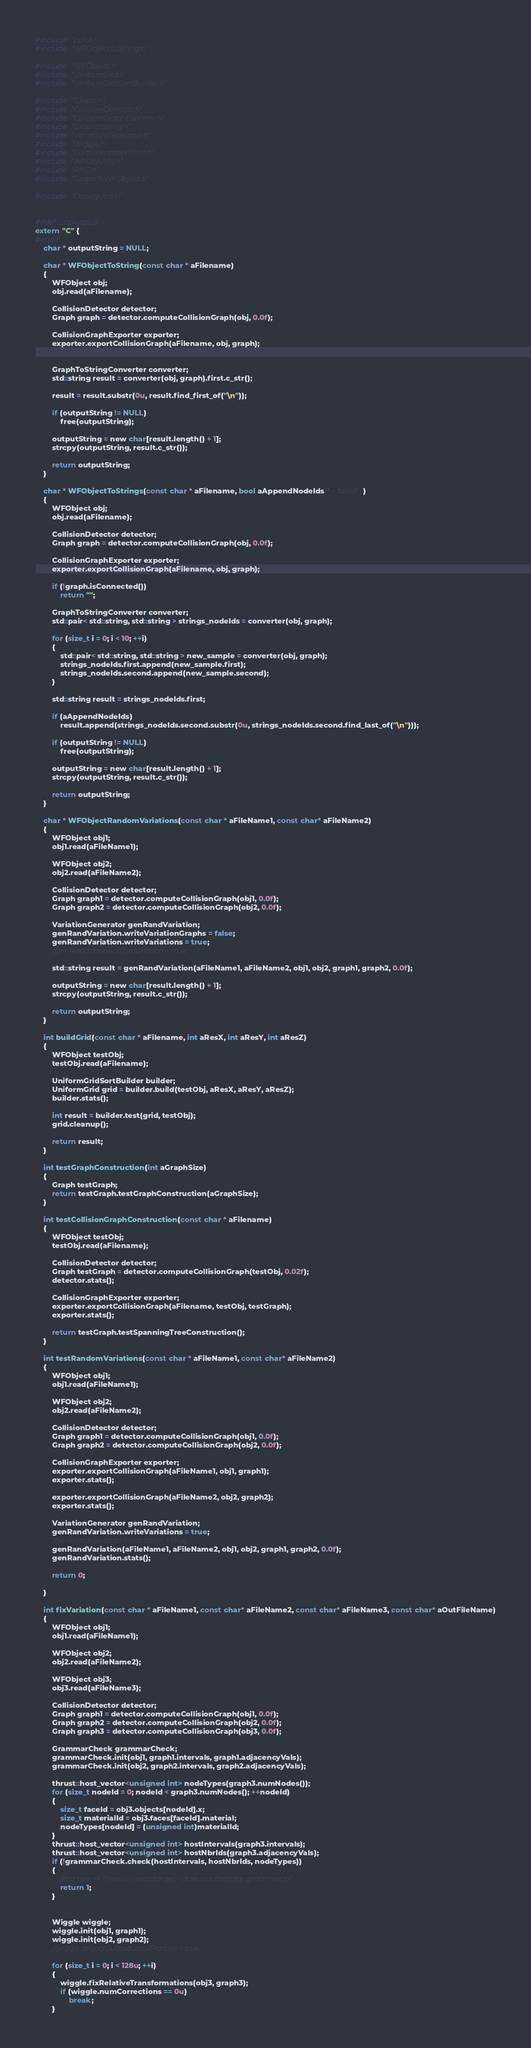<code> <loc_0><loc_0><loc_500><loc_500><_Cuda_>#include "pch.h"
#include "WFObjectToString.h"

#include "WFObject.h"
#include "UniformGrid.h"
#include "UniformGridSortBuilder.h"

#include "Graph.h"
#include "CollisionDetector.h"
#include "CollisionGraphExporter.h"
#include "Graph2String.h"
#include "VariationGenerator.h"
#include "Wiggle.h"
#include "PartOrientationUtils.h"
#include "WFObjUtils.h"
#include "RNG.h"
#include "GraphToWFObject.h"

#include "DebugUtils.h"


#ifdef __cplusplus
extern "C" {
#endif
	char * outputString = NULL;

	char * WFObjectToString(const char * aFilename)
	{
		WFObject obj;
		obj.read(aFilename);

		CollisionDetector detector;
		Graph graph = detector.computeCollisionGraph(obj, 0.0f);

		CollisionGraphExporter exporter;
		exporter.exportCollisionGraph(aFilename, obj, graph);


		GraphToStringConverter converter;
		std::string result = converter(obj, graph).first.c_str();
		
		result = result.substr(0u, result.find_first_of("\n"));

		if (outputString != NULL)
			free(outputString);

		outputString = new char[result.length() + 1];
		strcpy(outputString, result.c_str());

		return outputString;
	}

	char * WFObjectToStrings(const char * aFilename, bool aAppendNodeIds/* = false*/)
	{
		WFObject obj;
		obj.read(aFilename);

		CollisionDetector detector;
		Graph graph = detector.computeCollisionGraph(obj, 0.0f);

		CollisionGraphExporter exporter;
		exporter.exportCollisionGraph(aFilename, obj, graph);

		if (!graph.isConnected())
			return "";

		GraphToStringConverter converter;
		std::pair< std::string, std::string > strings_nodeIds = converter(obj, graph);

		for (size_t i = 0; i < 10; ++i)
		{
			std::pair< std::string, std::string > new_sample = converter(obj, graph);
			strings_nodeIds.first.append(new_sample.first);
			strings_nodeIds.second.append(new_sample.second);
		}

		std::string result = strings_nodeIds.first;

		if (aAppendNodeIds)
			result.append(strings_nodeIds.second.substr(0u, strings_nodeIds.second.find_last_of("\n")));

		if (outputString != NULL)
			free(outputString);

		outputString = new char[result.length() + 1];
		strcpy(outputString, result.c_str());

		return outputString;
	}

	char * WFObjectRandomVariations(const char * aFileName1, const char* aFileName2)
	{
		WFObject obj1;
		obj1.read(aFileName1);

		WFObject obj2;
		obj2.read(aFileName2);

		CollisionDetector detector;
		Graph graph1 = detector.computeCollisionGraph(obj1, 0.0f);
		Graph graph2 = detector.computeCollisionGraph(obj2, 0.0f);

		VariationGenerator genRandVariation;
		genRandVariation.writeVariationGraphs = false;
		genRandVariation.writeVariations = true;
		//genRandVariation.fixVariation = true;

		std::string result = genRandVariation(aFileName1, aFileName2, obj1, obj2, graph1, graph2, 0.0f);

		outputString = new char[result.length() + 1];
		strcpy(outputString, result.c_str());

		return outputString;
	}

	int buildGrid(const char * aFilename, int aResX, int aResY, int aResZ)
	{
		WFObject testObj;
		testObj.read(aFilename);

		UniformGridSortBuilder builder;
		UniformGrid grid = builder.build(testObj, aResX, aResY, aResZ);
		builder.stats();

		int result = builder.test(grid, testObj);
		grid.cleanup();

		return result;
	}

	int testGraphConstruction(int aGraphSize)
	{
		Graph testGraph;
		return testGraph.testGraphConstruction(aGraphSize);
	}

	int testCollisionGraphConstruction(const char * aFilename)
	{
		WFObject testObj;
		testObj.read(aFilename);

		CollisionDetector detector;
		Graph testGraph = detector.computeCollisionGraph(testObj, 0.02f);
		detector.stats();		

		CollisionGraphExporter exporter;
		exporter.exportCollisionGraph(aFilename, testObj, testGraph);
		exporter.stats();

		return testGraph.testSpanningTreeConstruction();
	}

	int testRandomVariations(const char * aFileName1, const char* aFileName2)
	{
		WFObject obj1;
		obj1.read(aFileName1);

		WFObject obj2;
		obj2.read(aFileName2);

		CollisionDetector detector;
		Graph graph1 = detector.computeCollisionGraph(obj1, 0.0f);
		Graph graph2 = detector.computeCollisionGraph(obj2, 0.0f);

		CollisionGraphExporter exporter;
		exporter.exportCollisionGraph(aFileName1, obj1, graph1);
		exporter.stats();

		exporter.exportCollisionGraph(aFileName2, obj2, graph2);
		exporter.stats();

		VariationGenerator genRandVariation;
		genRandVariation.writeVariations = true;
		//genRandVariation.fixVariation = true;
		genRandVariation(aFileName1, aFileName2, obj1, obj2, graph1, graph2, 0.0f);
		genRandVariation.stats();

		return 0;

	}

	int fixVariation(const char * aFileName1, const char* aFileName2, const char* aFileName3, const char* aOutFileName)
	{
		WFObject obj1;
		obj1.read(aFileName1);

		WFObject obj2;
		obj2.read(aFileName2);

		WFObject obj3;
		obj3.read(aFileName3);

		CollisionDetector detector;
		Graph graph1 = detector.computeCollisionGraph(obj1, 0.0f);
		Graph graph2 = detector.computeCollisionGraph(obj2, 0.0f);
		Graph graph3 = detector.computeCollisionGraph(obj3, 0.0f);

		GrammarCheck grammarCheck;
		grammarCheck.init(obj1, graph1.intervals, graph1.adjacencyVals);
		grammarCheck.init(obj2, graph2.intervals, graph2.adjacencyVals);

		thrust::host_vector<unsigned int> nodeTypes(graph3.numNodes());
		for (size_t nodeId = 0; nodeId < graph3.numNodes(); ++nodeId)
		{
			size_t faceId = obj3.objects[nodeId].x;
			size_t materialId = obj3.faces[faceId].material;
			nodeTypes[nodeId] = (unsigned int)materialId;
		}
		thrust::host_vector<unsigned int> hostIntervals(graph3.intervals);
		thrust::host_vector<unsigned int> hostNbrIds(graph3.adjacencyVals);
		if (!grammarCheck.check(hostIntervals, hostNbrIds, nodeTypes))
		{
			//std::cerr << "Invalid repair target - does not conform grammar.\n";
			return 1;
		}


		Wiggle wiggle;
		wiggle.init(obj1, graph1);
		wiggle.init(obj2, graph2);
		//wiggle.debugOutputLocalFrames = true;

		for (size_t i = 0; i < 128u; ++i)
		{
			wiggle.fixRelativeTransformations(obj3, graph3);
			if (wiggle.numCorrections == 0u)
				break;
		}
</code> 